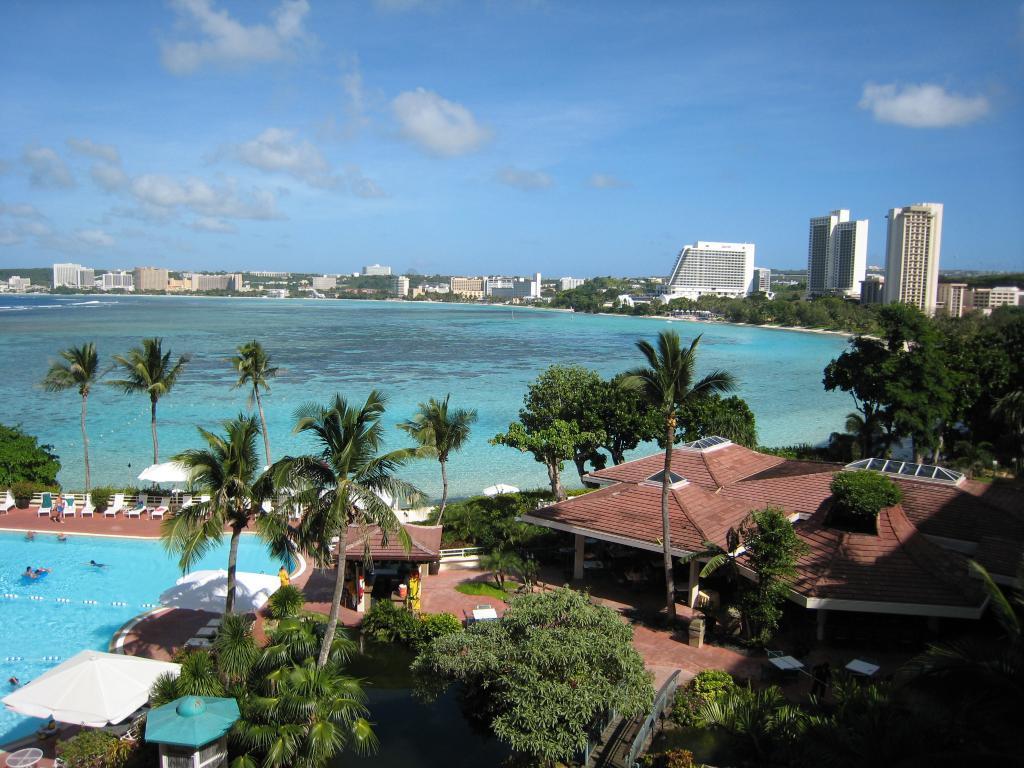Describe this image in one or two sentences. In the center of the image there is a sea and we can see trees. On the right there is a shed. On the left we can see a pool and there are people swimming in the pool. There are tents. In the background there are buildings and sky. 